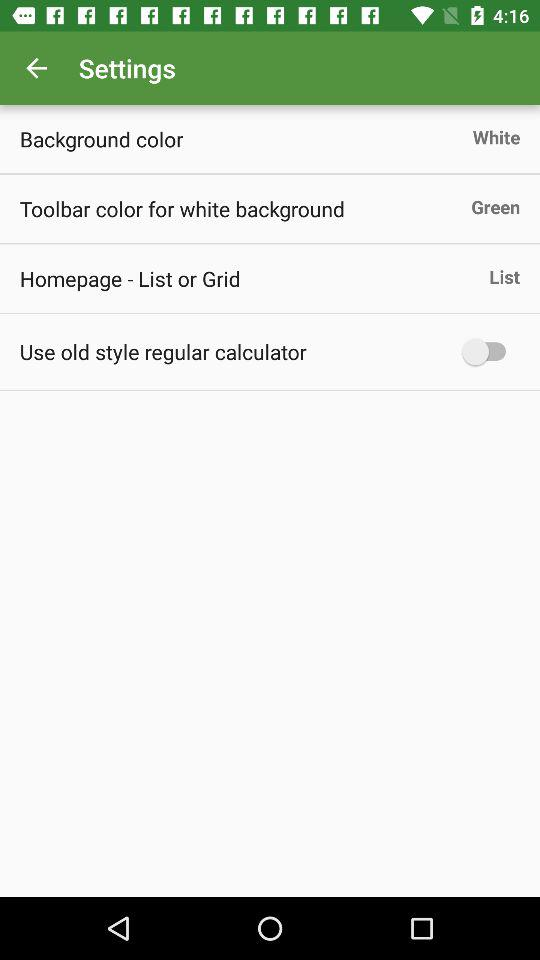What is the toolbar color for the white background? The toolbar color for the white background is green. 